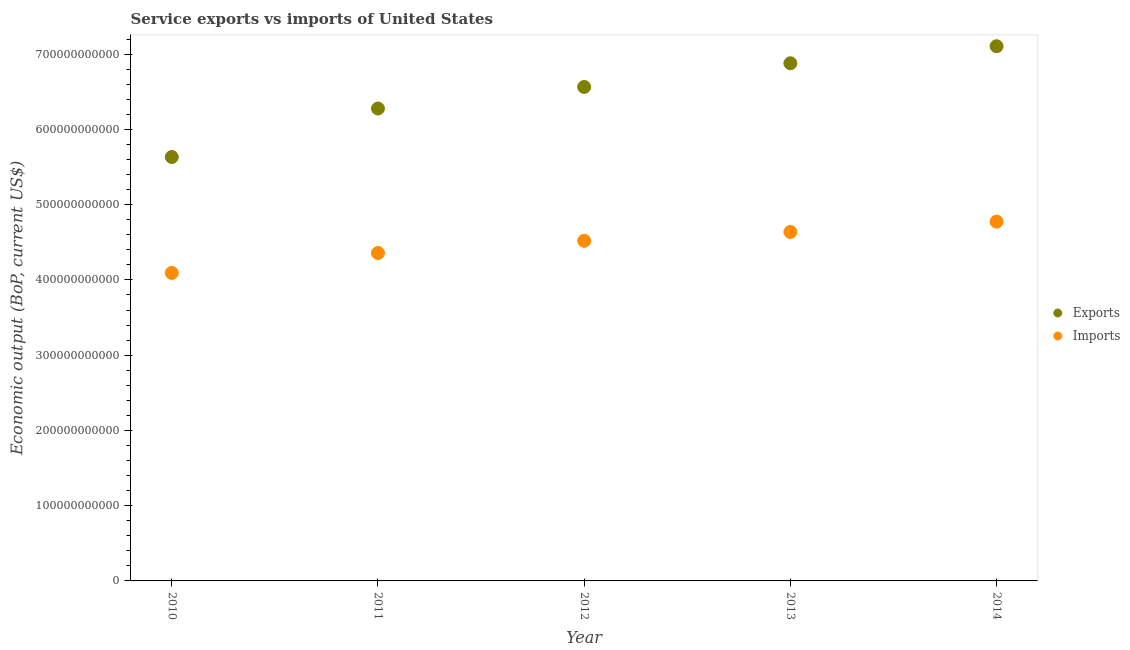What is the amount of service imports in 2010?
Provide a short and direct response. 4.09e+11. Across all years, what is the maximum amount of service imports?
Your answer should be compact. 4.77e+11. Across all years, what is the minimum amount of service imports?
Offer a terse response. 4.09e+11. In which year was the amount of service exports maximum?
Make the answer very short. 2014. In which year was the amount of service exports minimum?
Give a very brief answer. 2010. What is the total amount of service exports in the graph?
Ensure brevity in your answer.  3.25e+12. What is the difference between the amount of service exports in 2011 and that in 2012?
Ensure brevity in your answer.  -2.86e+1. What is the difference between the amount of service exports in 2011 and the amount of service imports in 2014?
Your response must be concise. 1.50e+11. What is the average amount of service exports per year?
Your answer should be compact. 6.49e+11. In the year 2014, what is the difference between the amount of service exports and amount of service imports?
Make the answer very short. 2.33e+11. What is the ratio of the amount of service imports in 2010 to that in 2011?
Ensure brevity in your answer.  0.94. Is the amount of service exports in 2011 less than that in 2012?
Make the answer very short. Yes. Is the difference between the amount of service exports in 2010 and 2012 greater than the difference between the amount of service imports in 2010 and 2012?
Provide a succinct answer. No. What is the difference between the highest and the second highest amount of service exports?
Offer a very short reply. 2.27e+1. What is the difference between the highest and the lowest amount of service imports?
Make the answer very short. 6.81e+1. Is the amount of service exports strictly greater than the amount of service imports over the years?
Your answer should be very brief. Yes. How many dotlines are there?
Keep it short and to the point. 2. What is the difference between two consecutive major ticks on the Y-axis?
Give a very brief answer. 1.00e+11. Are the values on the major ticks of Y-axis written in scientific E-notation?
Ensure brevity in your answer.  No. Does the graph contain any zero values?
Your response must be concise. No. Where does the legend appear in the graph?
Your answer should be very brief. Center right. How many legend labels are there?
Your response must be concise. 2. How are the legend labels stacked?
Your answer should be very brief. Vertical. What is the title of the graph?
Make the answer very short. Service exports vs imports of United States. What is the label or title of the Y-axis?
Ensure brevity in your answer.  Economic output (BoP, current US$). What is the Economic output (BoP, current US$) in Exports in 2010?
Your response must be concise. 5.63e+11. What is the Economic output (BoP, current US$) of Imports in 2010?
Provide a succinct answer. 4.09e+11. What is the Economic output (BoP, current US$) of Exports in 2011?
Make the answer very short. 6.28e+11. What is the Economic output (BoP, current US$) in Imports in 2011?
Make the answer very short. 4.36e+11. What is the Economic output (BoP, current US$) of Exports in 2012?
Ensure brevity in your answer.  6.56e+11. What is the Economic output (BoP, current US$) of Imports in 2012?
Provide a short and direct response. 4.52e+11. What is the Economic output (BoP, current US$) of Exports in 2013?
Offer a terse response. 6.88e+11. What is the Economic output (BoP, current US$) of Imports in 2013?
Offer a very short reply. 4.64e+11. What is the Economic output (BoP, current US$) of Exports in 2014?
Keep it short and to the point. 7.11e+11. What is the Economic output (BoP, current US$) of Imports in 2014?
Offer a very short reply. 4.77e+11. Across all years, what is the maximum Economic output (BoP, current US$) of Exports?
Your answer should be very brief. 7.11e+11. Across all years, what is the maximum Economic output (BoP, current US$) of Imports?
Your answer should be very brief. 4.77e+11. Across all years, what is the minimum Economic output (BoP, current US$) in Exports?
Offer a very short reply. 5.63e+11. Across all years, what is the minimum Economic output (BoP, current US$) in Imports?
Offer a very short reply. 4.09e+11. What is the total Economic output (BoP, current US$) of Exports in the graph?
Your response must be concise. 3.25e+12. What is the total Economic output (BoP, current US$) of Imports in the graph?
Provide a short and direct response. 2.24e+12. What is the difference between the Economic output (BoP, current US$) in Exports in 2010 and that in 2011?
Your answer should be compact. -6.44e+1. What is the difference between the Economic output (BoP, current US$) of Imports in 2010 and that in 2011?
Your answer should be very brief. -2.65e+1. What is the difference between the Economic output (BoP, current US$) in Exports in 2010 and that in 2012?
Your answer should be compact. -9.31e+1. What is the difference between the Economic output (BoP, current US$) of Imports in 2010 and that in 2012?
Ensure brevity in your answer.  -4.27e+1. What is the difference between the Economic output (BoP, current US$) of Exports in 2010 and that in 2013?
Offer a very short reply. -1.25e+11. What is the difference between the Economic output (BoP, current US$) in Imports in 2010 and that in 2013?
Offer a terse response. -5.44e+1. What is the difference between the Economic output (BoP, current US$) in Exports in 2010 and that in 2014?
Make the answer very short. -1.47e+11. What is the difference between the Economic output (BoP, current US$) in Imports in 2010 and that in 2014?
Provide a short and direct response. -6.81e+1. What is the difference between the Economic output (BoP, current US$) of Exports in 2011 and that in 2012?
Make the answer very short. -2.86e+1. What is the difference between the Economic output (BoP, current US$) of Imports in 2011 and that in 2012?
Make the answer very short. -1.62e+1. What is the difference between the Economic output (BoP, current US$) in Exports in 2011 and that in 2013?
Ensure brevity in your answer.  -6.01e+1. What is the difference between the Economic output (BoP, current US$) in Imports in 2011 and that in 2013?
Provide a short and direct response. -2.79e+1. What is the difference between the Economic output (BoP, current US$) of Exports in 2011 and that in 2014?
Provide a succinct answer. -8.28e+1. What is the difference between the Economic output (BoP, current US$) in Imports in 2011 and that in 2014?
Offer a terse response. -4.17e+1. What is the difference between the Economic output (BoP, current US$) in Exports in 2012 and that in 2013?
Provide a short and direct response. -3.15e+1. What is the difference between the Economic output (BoP, current US$) in Imports in 2012 and that in 2013?
Ensure brevity in your answer.  -1.17e+1. What is the difference between the Economic output (BoP, current US$) of Exports in 2012 and that in 2014?
Provide a short and direct response. -5.42e+1. What is the difference between the Economic output (BoP, current US$) in Imports in 2012 and that in 2014?
Provide a short and direct response. -2.54e+1. What is the difference between the Economic output (BoP, current US$) of Exports in 2013 and that in 2014?
Your answer should be very brief. -2.27e+1. What is the difference between the Economic output (BoP, current US$) of Imports in 2013 and that in 2014?
Provide a short and direct response. -1.37e+1. What is the difference between the Economic output (BoP, current US$) in Exports in 2010 and the Economic output (BoP, current US$) in Imports in 2011?
Your answer should be very brief. 1.28e+11. What is the difference between the Economic output (BoP, current US$) of Exports in 2010 and the Economic output (BoP, current US$) of Imports in 2012?
Give a very brief answer. 1.11e+11. What is the difference between the Economic output (BoP, current US$) in Exports in 2010 and the Economic output (BoP, current US$) in Imports in 2013?
Keep it short and to the point. 9.96e+1. What is the difference between the Economic output (BoP, current US$) in Exports in 2010 and the Economic output (BoP, current US$) in Imports in 2014?
Make the answer very short. 8.59e+1. What is the difference between the Economic output (BoP, current US$) of Exports in 2011 and the Economic output (BoP, current US$) of Imports in 2012?
Provide a succinct answer. 1.76e+11. What is the difference between the Economic output (BoP, current US$) of Exports in 2011 and the Economic output (BoP, current US$) of Imports in 2013?
Offer a terse response. 1.64e+11. What is the difference between the Economic output (BoP, current US$) of Exports in 2011 and the Economic output (BoP, current US$) of Imports in 2014?
Ensure brevity in your answer.  1.50e+11. What is the difference between the Economic output (BoP, current US$) in Exports in 2012 and the Economic output (BoP, current US$) in Imports in 2013?
Provide a short and direct response. 1.93e+11. What is the difference between the Economic output (BoP, current US$) of Exports in 2012 and the Economic output (BoP, current US$) of Imports in 2014?
Your answer should be compact. 1.79e+11. What is the difference between the Economic output (BoP, current US$) in Exports in 2013 and the Economic output (BoP, current US$) in Imports in 2014?
Your answer should be very brief. 2.10e+11. What is the average Economic output (BoP, current US$) in Exports per year?
Ensure brevity in your answer.  6.49e+11. What is the average Economic output (BoP, current US$) in Imports per year?
Provide a short and direct response. 4.48e+11. In the year 2010, what is the difference between the Economic output (BoP, current US$) in Exports and Economic output (BoP, current US$) in Imports?
Make the answer very short. 1.54e+11. In the year 2011, what is the difference between the Economic output (BoP, current US$) of Exports and Economic output (BoP, current US$) of Imports?
Your response must be concise. 1.92e+11. In the year 2012, what is the difference between the Economic output (BoP, current US$) in Exports and Economic output (BoP, current US$) in Imports?
Your answer should be compact. 2.04e+11. In the year 2013, what is the difference between the Economic output (BoP, current US$) in Exports and Economic output (BoP, current US$) in Imports?
Provide a short and direct response. 2.24e+11. In the year 2014, what is the difference between the Economic output (BoP, current US$) in Exports and Economic output (BoP, current US$) in Imports?
Your answer should be compact. 2.33e+11. What is the ratio of the Economic output (BoP, current US$) in Exports in 2010 to that in 2011?
Your answer should be very brief. 0.9. What is the ratio of the Economic output (BoP, current US$) in Imports in 2010 to that in 2011?
Give a very brief answer. 0.94. What is the ratio of the Economic output (BoP, current US$) of Exports in 2010 to that in 2012?
Provide a succinct answer. 0.86. What is the ratio of the Economic output (BoP, current US$) of Imports in 2010 to that in 2012?
Provide a succinct answer. 0.91. What is the ratio of the Economic output (BoP, current US$) of Exports in 2010 to that in 2013?
Ensure brevity in your answer.  0.82. What is the ratio of the Economic output (BoP, current US$) of Imports in 2010 to that in 2013?
Your answer should be very brief. 0.88. What is the ratio of the Economic output (BoP, current US$) in Exports in 2010 to that in 2014?
Your response must be concise. 0.79. What is the ratio of the Economic output (BoP, current US$) in Imports in 2010 to that in 2014?
Offer a very short reply. 0.86. What is the ratio of the Economic output (BoP, current US$) of Exports in 2011 to that in 2012?
Provide a succinct answer. 0.96. What is the ratio of the Economic output (BoP, current US$) of Imports in 2011 to that in 2012?
Your response must be concise. 0.96. What is the ratio of the Economic output (BoP, current US$) in Exports in 2011 to that in 2013?
Offer a terse response. 0.91. What is the ratio of the Economic output (BoP, current US$) in Imports in 2011 to that in 2013?
Your answer should be very brief. 0.94. What is the ratio of the Economic output (BoP, current US$) of Exports in 2011 to that in 2014?
Provide a succinct answer. 0.88. What is the ratio of the Economic output (BoP, current US$) in Imports in 2011 to that in 2014?
Your response must be concise. 0.91. What is the ratio of the Economic output (BoP, current US$) in Exports in 2012 to that in 2013?
Offer a terse response. 0.95. What is the ratio of the Economic output (BoP, current US$) of Imports in 2012 to that in 2013?
Provide a succinct answer. 0.97. What is the ratio of the Economic output (BoP, current US$) of Exports in 2012 to that in 2014?
Provide a short and direct response. 0.92. What is the ratio of the Economic output (BoP, current US$) in Imports in 2012 to that in 2014?
Keep it short and to the point. 0.95. What is the ratio of the Economic output (BoP, current US$) in Exports in 2013 to that in 2014?
Keep it short and to the point. 0.97. What is the ratio of the Economic output (BoP, current US$) of Imports in 2013 to that in 2014?
Provide a succinct answer. 0.97. What is the difference between the highest and the second highest Economic output (BoP, current US$) in Exports?
Give a very brief answer. 2.27e+1. What is the difference between the highest and the second highest Economic output (BoP, current US$) of Imports?
Your answer should be very brief. 1.37e+1. What is the difference between the highest and the lowest Economic output (BoP, current US$) of Exports?
Give a very brief answer. 1.47e+11. What is the difference between the highest and the lowest Economic output (BoP, current US$) in Imports?
Offer a very short reply. 6.81e+1. 